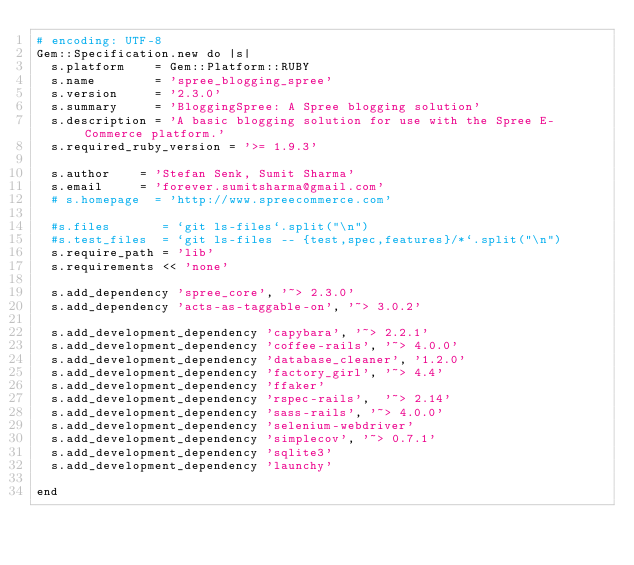<code> <loc_0><loc_0><loc_500><loc_500><_Ruby_># encoding: UTF-8
Gem::Specification.new do |s|
  s.platform    = Gem::Platform::RUBY
  s.name        = 'spree_blogging_spree'
  s.version     = '2.3.0'
  s.summary     = 'BloggingSpree: A Spree blogging solution'
  s.description = 'A basic blogging solution for use with the Spree E-Commerce platform.'
  s.required_ruby_version = '>= 1.9.3'

  s.author    = 'Stefan Senk, Sumit Sharma'
  s.email     = 'forever.sumitsharma@gmail.com'
  # s.homepage  = 'http://www.spreecommerce.com'

  #s.files       = `git ls-files`.split("\n")
  #s.test_files  = `git ls-files -- {test,spec,features}/*`.split("\n")
  s.require_path = 'lib'
  s.requirements << 'none'

  s.add_dependency 'spree_core', '~> 2.3.0'
  s.add_dependency 'acts-as-taggable-on', '~> 3.0.2'

  s.add_development_dependency 'capybara', '~> 2.2.1'
  s.add_development_dependency 'coffee-rails', '~> 4.0.0'
  s.add_development_dependency 'database_cleaner', '1.2.0'
  s.add_development_dependency 'factory_girl', '~> 4.4'
  s.add_development_dependency 'ffaker'
  s.add_development_dependency 'rspec-rails',  '~> 2.14'
  s.add_development_dependency 'sass-rails', '~> 4.0.0'
  s.add_development_dependency 'selenium-webdriver'
  s.add_development_dependency 'simplecov', '~> 0.7.1'
  s.add_development_dependency 'sqlite3'
  s.add_development_dependency 'launchy'

end
</code> 